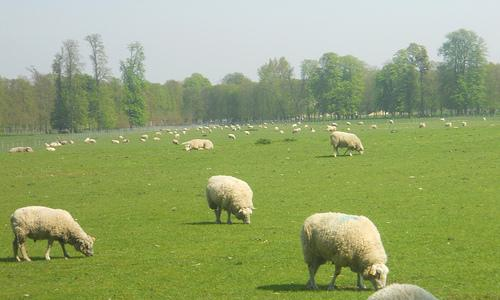Point out the most dominant feature of the image. The most dominant feature of the image is the large green field filled with white sheep grazing on the grass. Provide a brief description of the most prominent object in the image and its surroundings. A large green field is filled with white sheep grazing on the grass, surrounded by a row of green trees and a grey sky overhead. Identify and describe the setting in which the image takes place. The image is set in a large green field with several white sheep grazing, bordered by green trees and a grey sky above. Discuss the focal point of the image and the overall mood. The focal point of the image is the field of white sheep grazing on the green grass, surrounded by green trees and a grey sky, creating a serene and peaceful mood. Mention the activities happening in the image. The activities taking place in the image are white sheep grazing on the green grass and standing on the field. List the primary colors and elements seen in the image. Green: field, trees; White: sheep; Grey: sky; Brown: legs of the sheep. Describe the image focusing on the location and environment. The location is a vast, green field where white sheep are grazing, with a row of green trees adorning the background and a grey sky above. Mention what the animals in the image are doing. The white sheep are grazing on the green grass in the field. Write a brief narrative about the scene depicted in the image. On a cloudy day, a group of white sheep peacefully graze on lush green grass in a spacious field, as a row of trees adorns the background. Summarize the main elements visible in the image. The image features a green field with numerous white sheep grazing, green trees, and a grey sky. 